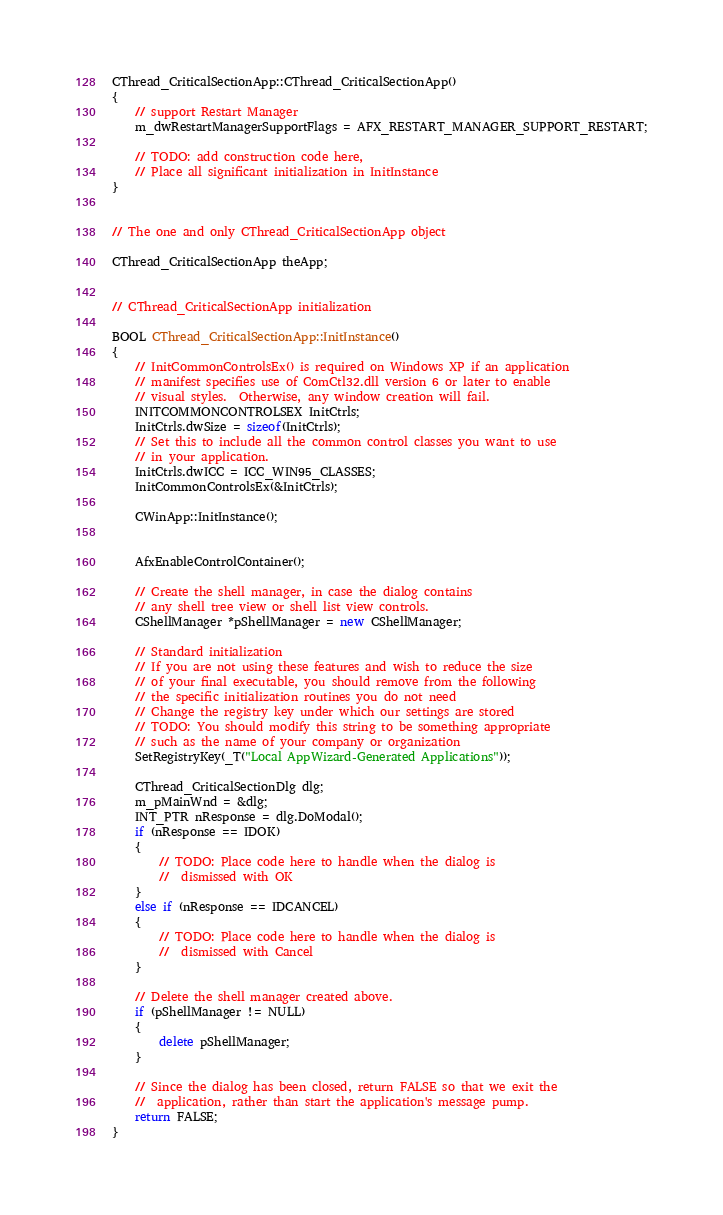<code> <loc_0><loc_0><loc_500><loc_500><_C++_>
CThread_CriticalSectionApp::CThread_CriticalSectionApp()
{
	// support Restart Manager
	m_dwRestartManagerSupportFlags = AFX_RESTART_MANAGER_SUPPORT_RESTART;

	// TODO: add construction code here,
	// Place all significant initialization in InitInstance
}


// The one and only CThread_CriticalSectionApp object

CThread_CriticalSectionApp theApp;


// CThread_CriticalSectionApp initialization

BOOL CThread_CriticalSectionApp::InitInstance()
{
	// InitCommonControlsEx() is required on Windows XP if an application
	// manifest specifies use of ComCtl32.dll version 6 or later to enable
	// visual styles.  Otherwise, any window creation will fail.
	INITCOMMONCONTROLSEX InitCtrls;
	InitCtrls.dwSize = sizeof(InitCtrls);
	// Set this to include all the common control classes you want to use
	// in your application.
	InitCtrls.dwICC = ICC_WIN95_CLASSES;
	InitCommonControlsEx(&InitCtrls);

	CWinApp::InitInstance();


	AfxEnableControlContainer();

	// Create the shell manager, in case the dialog contains
	// any shell tree view or shell list view controls.
	CShellManager *pShellManager = new CShellManager;

	// Standard initialization
	// If you are not using these features and wish to reduce the size
	// of your final executable, you should remove from the following
	// the specific initialization routines you do not need
	// Change the registry key under which our settings are stored
	// TODO: You should modify this string to be something appropriate
	// such as the name of your company or organization
	SetRegistryKey(_T("Local AppWizard-Generated Applications"));

	CThread_CriticalSectionDlg dlg;
	m_pMainWnd = &dlg;
	INT_PTR nResponse = dlg.DoModal();
	if (nResponse == IDOK)
	{
		// TODO: Place code here to handle when the dialog is
		//  dismissed with OK
	}
	else if (nResponse == IDCANCEL)
	{
		// TODO: Place code here to handle when the dialog is
		//  dismissed with Cancel
	}

	// Delete the shell manager created above.
	if (pShellManager != NULL)
	{
		delete pShellManager;
	}

	// Since the dialog has been closed, return FALSE so that we exit the
	//  application, rather than start the application's message pump.
	return FALSE;
}

</code> 